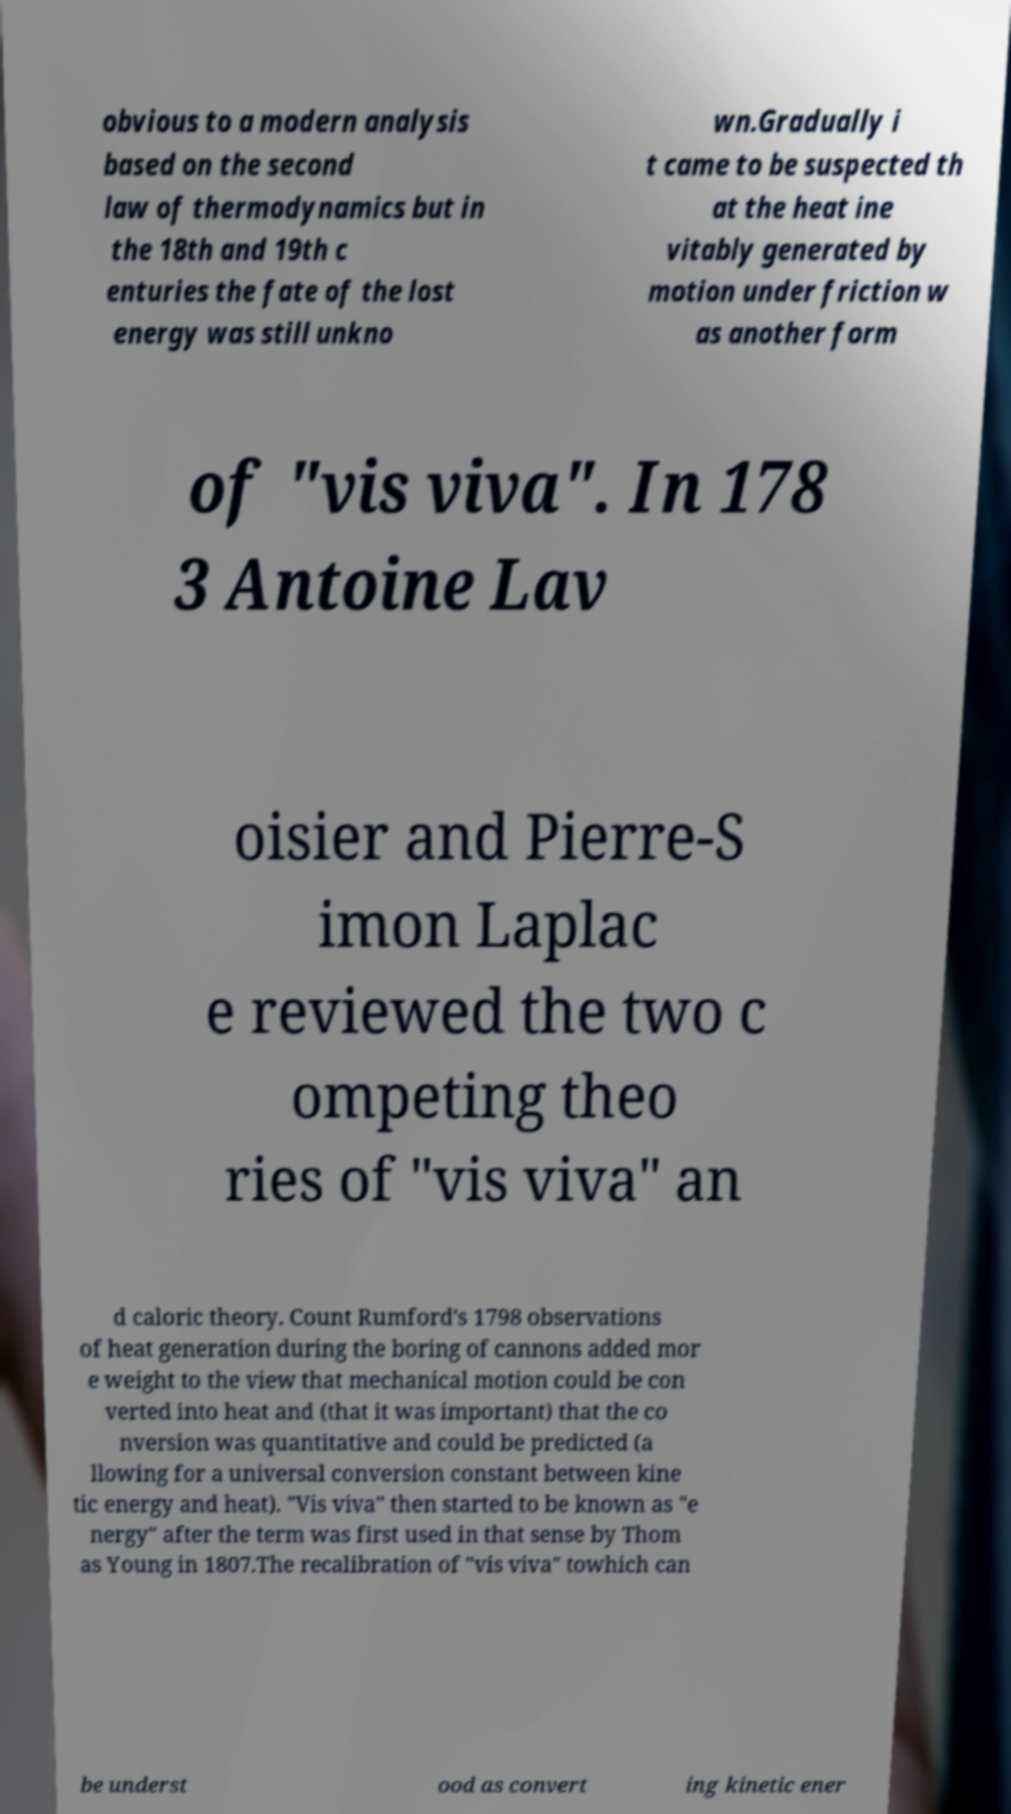Can you accurately transcribe the text from the provided image for me? obvious to a modern analysis based on the second law of thermodynamics but in the 18th and 19th c enturies the fate of the lost energy was still unkno wn.Gradually i t came to be suspected th at the heat ine vitably generated by motion under friction w as another form of "vis viva". In 178 3 Antoine Lav oisier and Pierre-S imon Laplac e reviewed the two c ompeting theo ries of "vis viva" an d caloric theory. Count Rumford's 1798 observations of heat generation during the boring of cannons added mor e weight to the view that mechanical motion could be con verted into heat and (that it was important) that the co nversion was quantitative and could be predicted (a llowing for a universal conversion constant between kine tic energy and heat). "Vis viva" then started to be known as "e nergy" after the term was first used in that sense by Thom as Young in 1807.The recalibration of "vis viva" towhich can be underst ood as convert ing kinetic ener 